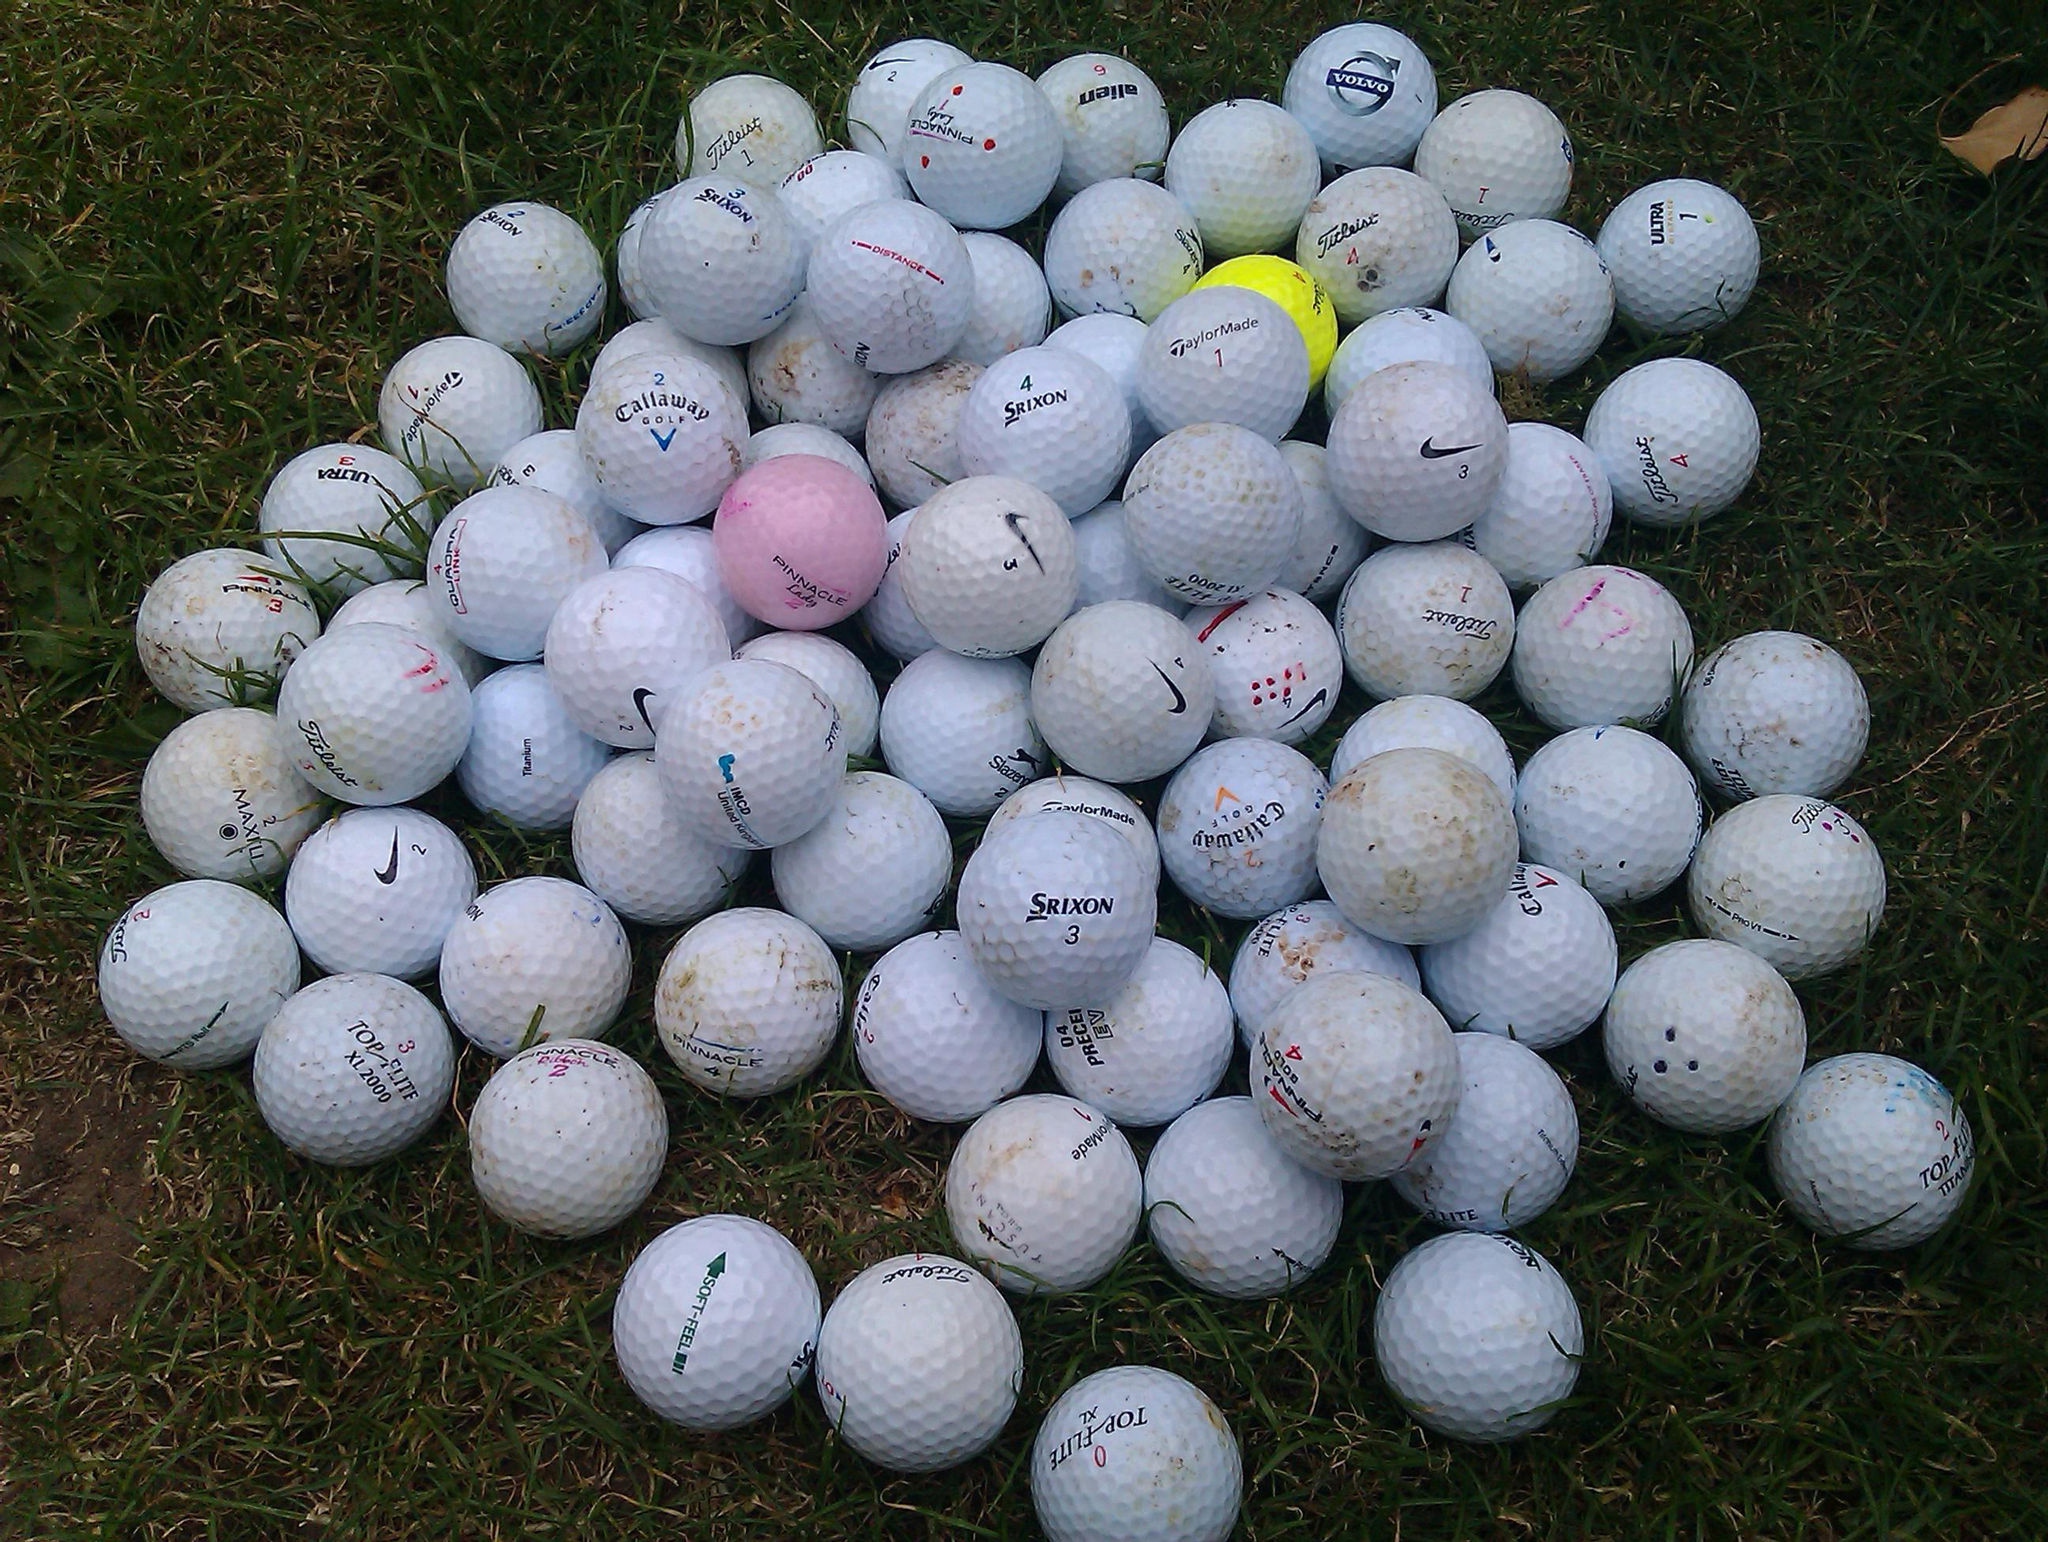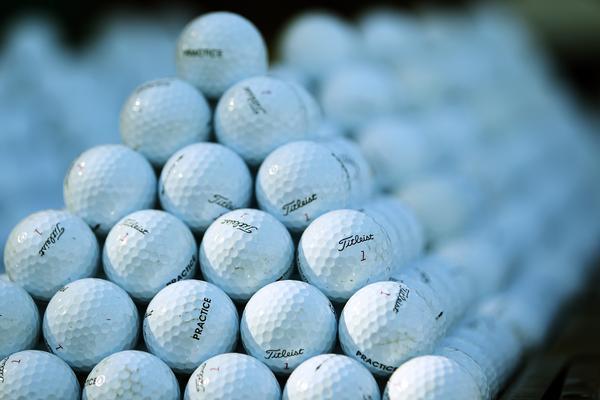The first image is the image on the left, the second image is the image on the right. Given the left and right images, does the statement "A pile of used golf balls includes at least one pink and one yellow ball." hold true? Answer yes or no. Yes. The first image is the image on the left, the second image is the image on the right. Considering the images on both sides, is "Some of the balls are in a clear container in one of the images." valid? Answer yes or no. No. 